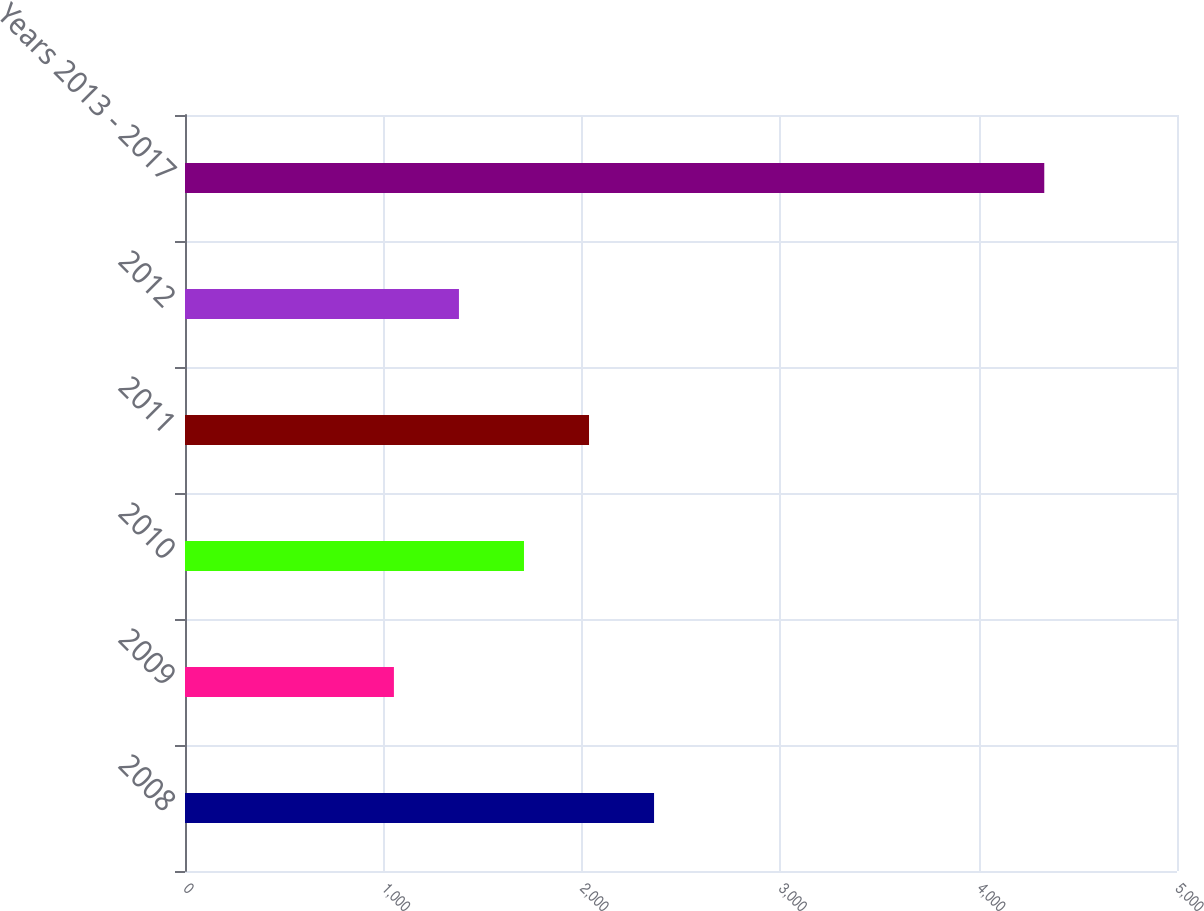Convert chart. <chart><loc_0><loc_0><loc_500><loc_500><bar_chart><fcel>2008<fcel>2009<fcel>2010<fcel>2011<fcel>2012<fcel>Years 2013 - 2017<nl><fcel>2364.2<fcel>1053<fcel>1708.6<fcel>2036.4<fcel>1380.8<fcel>4331<nl></chart> 